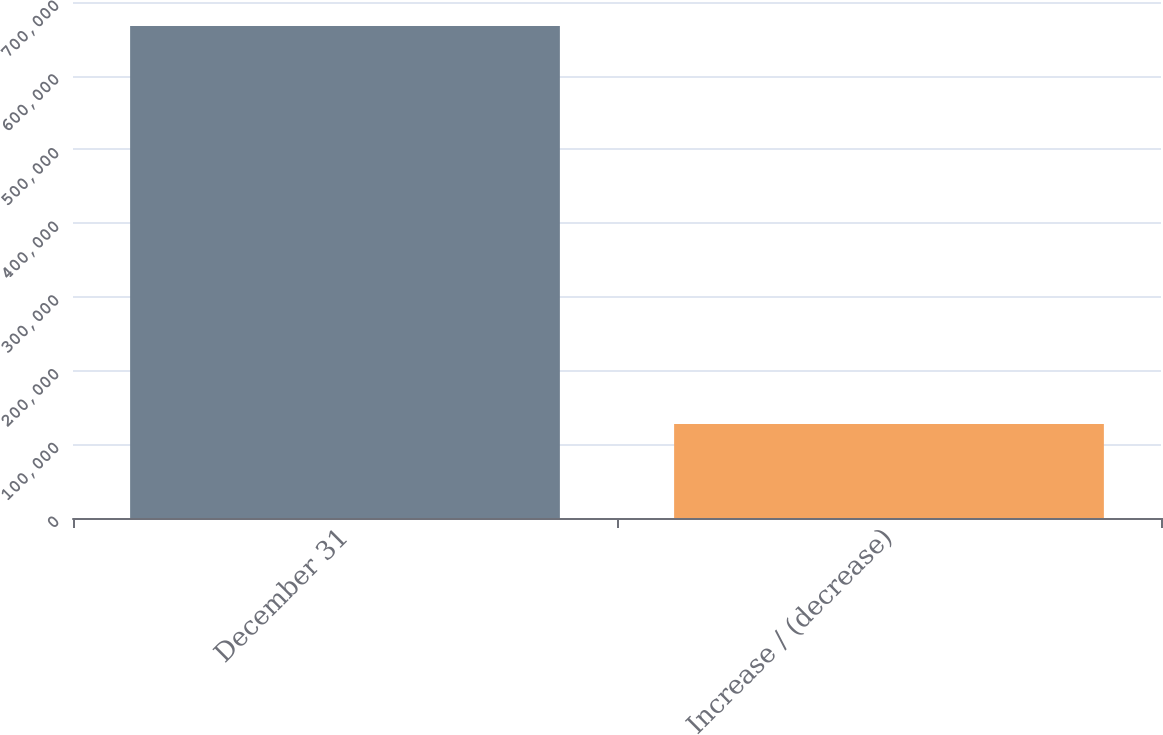Convert chart. <chart><loc_0><loc_0><loc_500><loc_500><bar_chart><fcel>December 31<fcel>Increase / (decrease)<nl><fcel>667285<fcel>127659<nl></chart> 